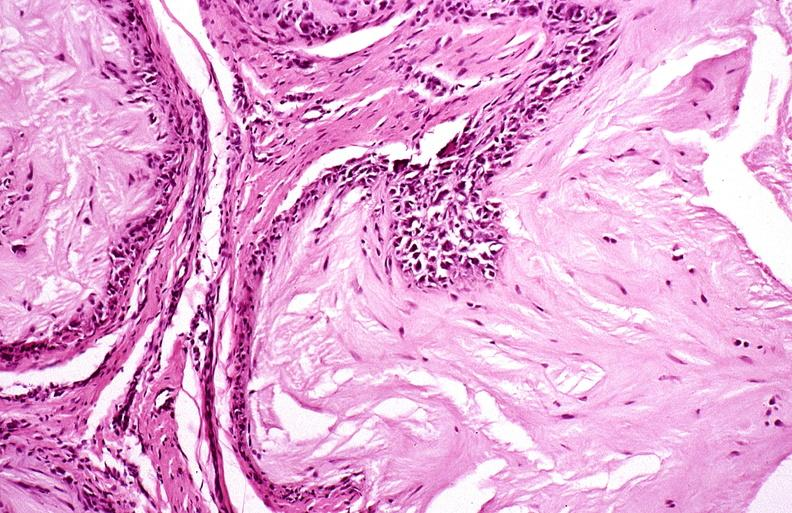does this image show gout?
Answer the question using a single word or phrase. Yes 